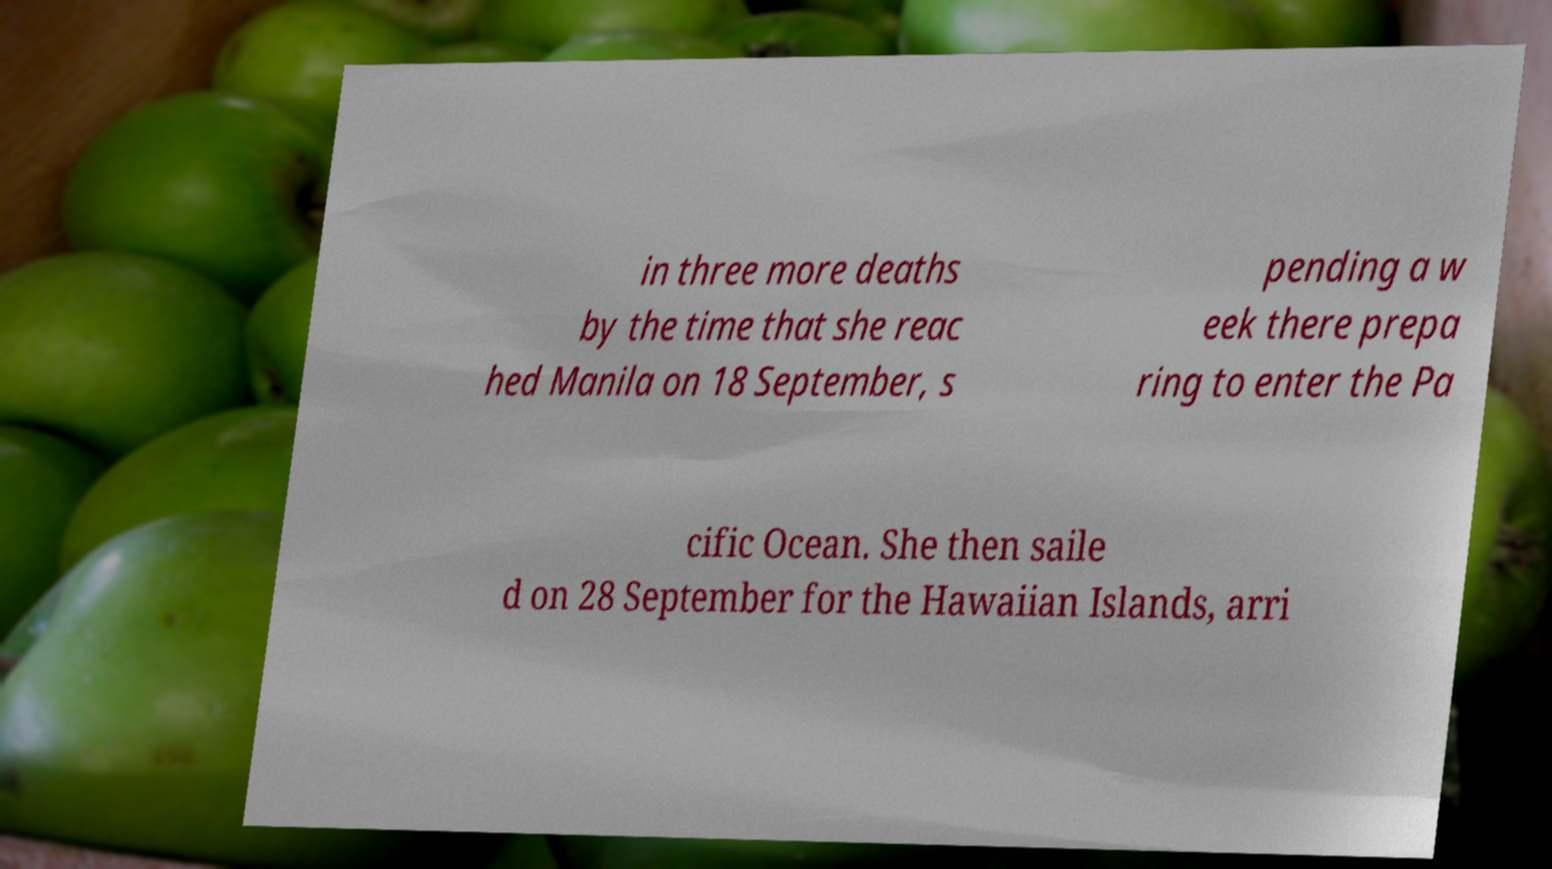There's text embedded in this image that I need extracted. Can you transcribe it verbatim? in three more deaths by the time that she reac hed Manila on 18 September, s pending a w eek there prepa ring to enter the Pa cific Ocean. She then saile d on 28 September for the Hawaiian Islands, arri 